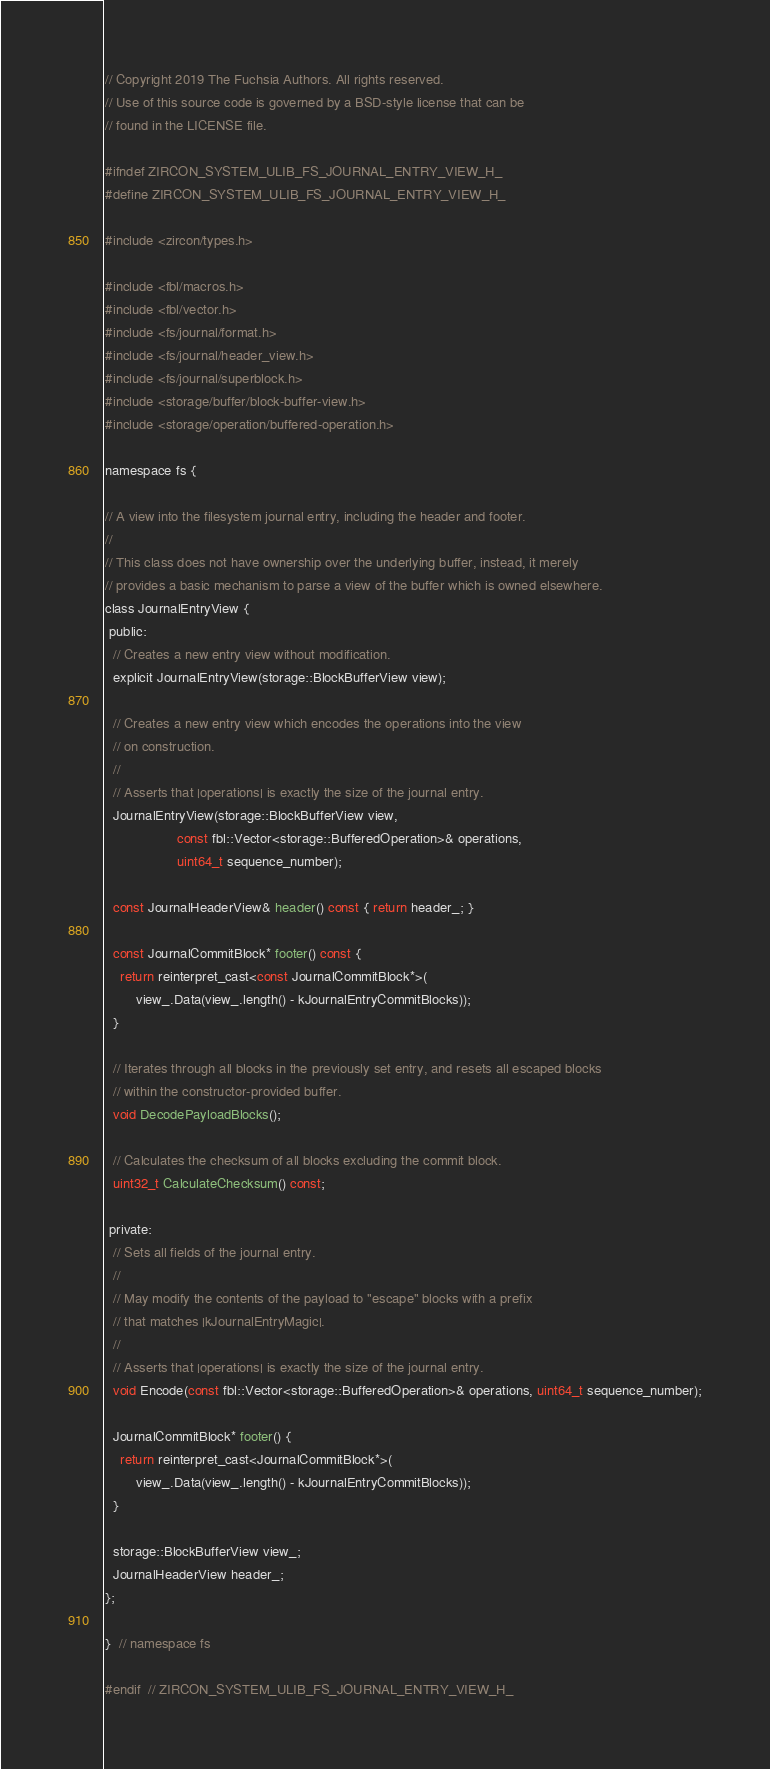Convert code to text. <code><loc_0><loc_0><loc_500><loc_500><_C_>// Copyright 2019 The Fuchsia Authors. All rights reserved.
// Use of this source code is governed by a BSD-style license that can be
// found in the LICENSE file.

#ifndef ZIRCON_SYSTEM_ULIB_FS_JOURNAL_ENTRY_VIEW_H_
#define ZIRCON_SYSTEM_ULIB_FS_JOURNAL_ENTRY_VIEW_H_

#include <zircon/types.h>

#include <fbl/macros.h>
#include <fbl/vector.h>
#include <fs/journal/format.h>
#include <fs/journal/header_view.h>
#include <fs/journal/superblock.h>
#include <storage/buffer/block-buffer-view.h>
#include <storage/operation/buffered-operation.h>

namespace fs {

// A view into the filesystem journal entry, including the header and footer.
//
// This class does not have ownership over the underlying buffer, instead, it merely
// provides a basic mechanism to parse a view of the buffer which is owned elsewhere.
class JournalEntryView {
 public:
  // Creates a new entry view without modification.
  explicit JournalEntryView(storage::BlockBufferView view);

  // Creates a new entry view which encodes the operations into the view
  // on construction.
  //
  // Asserts that |operations| is exactly the size of the journal entry.
  JournalEntryView(storage::BlockBufferView view,
                   const fbl::Vector<storage::BufferedOperation>& operations,
                   uint64_t sequence_number);

  const JournalHeaderView& header() const { return header_; }

  const JournalCommitBlock* footer() const {
    return reinterpret_cast<const JournalCommitBlock*>(
        view_.Data(view_.length() - kJournalEntryCommitBlocks));
  }

  // Iterates through all blocks in the previously set entry, and resets all escaped blocks
  // within the constructor-provided buffer.
  void DecodePayloadBlocks();

  // Calculates the checksum of all blocks excluding the commit block.
  uint32_t CalculateChecksum() const;

 private:
  // Sets all fields of the journal entry.
  //
  // May modify the contents of the payload to "escape" blocks with a prefix
  // that matches |kJournalEntryMagic|.
  //
  // Asserts that |operations| is exactly the size of the journal entry.
  void Encode(const fbl::Vector<storage::BufferedOperation>& operations, uint64_t sequence_number);

  JournalCommitBlock* footer() {
    return reinterpret_cast<JournalCommitBlock*>(
        view_.Data(view_.length() - kJournalEntryCommitBlocks));
  }

  storage::BlockBufferView view_;
  JournalHeaderView header_;
};

}  // namespace fs

#endif  // ZIRCON_SYSTEM_ULIB_FS_JOURNAL_ENTRY_VIEW_H_
</code> 